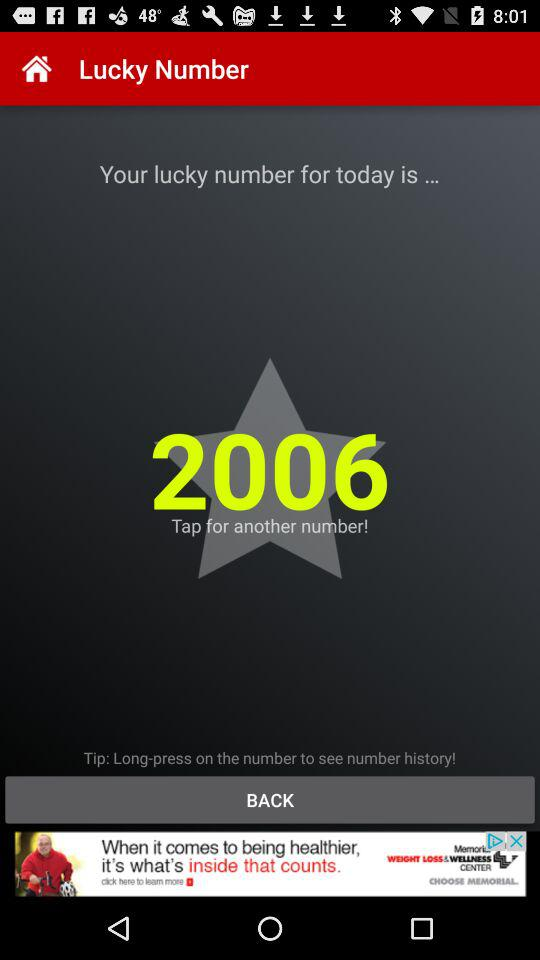How many digits are in the lucky number?
Answer the question using a single word or phrase. 4 